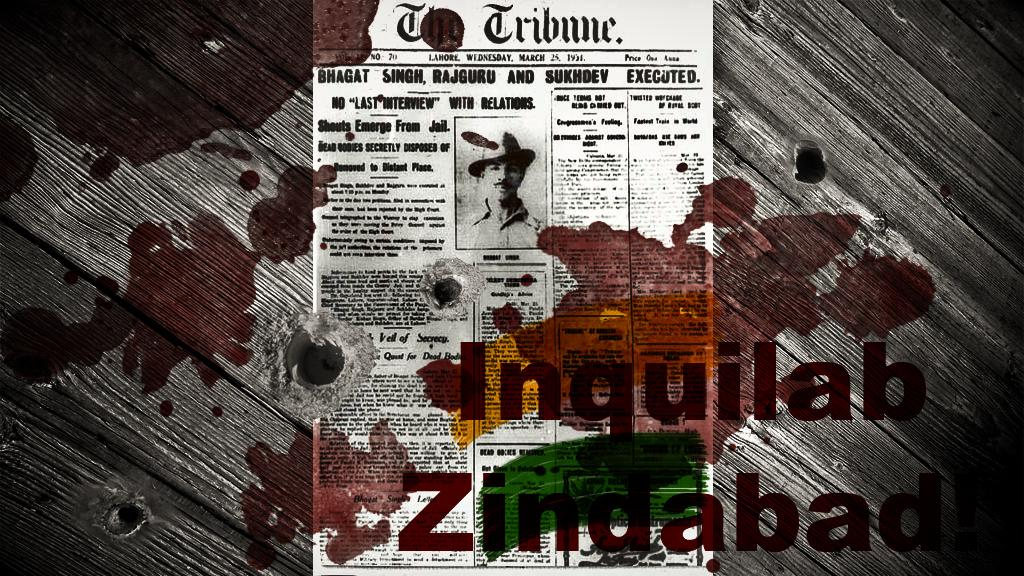<image>
Describe the image concisely. A bloody newspaper from the Tribune on wood 